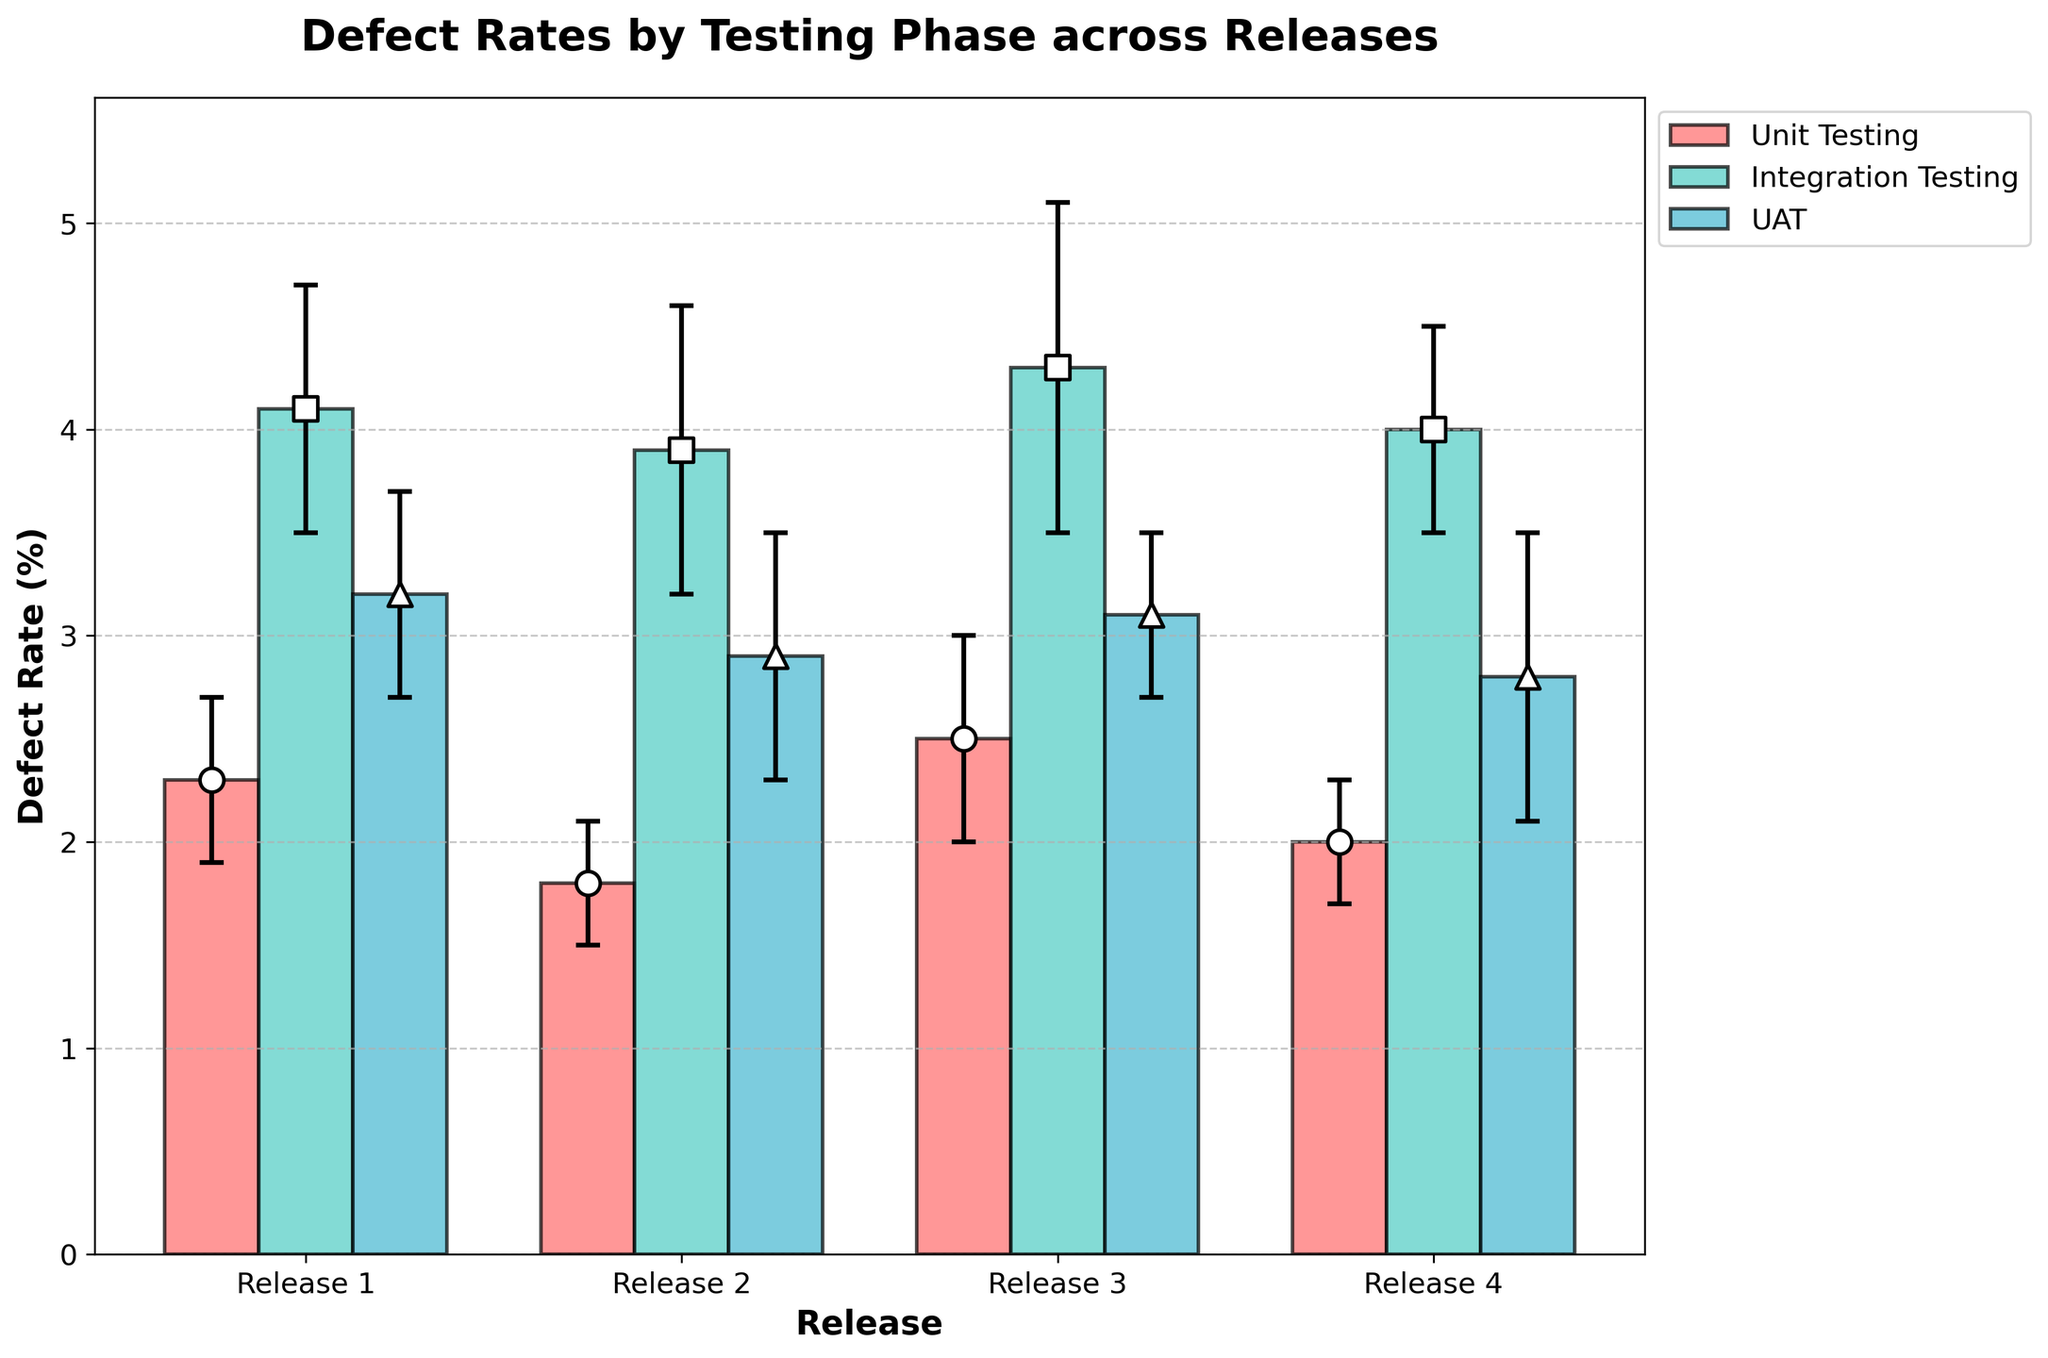What's the title of the figure? The title of the figure is usually prominently displayed at the top. In this figure, the title is "Defect Rates by Testing Phase across Releases".
Answer: Defect Rates by Testing Phase across Releases Which testing phase has the highest defect rate in Release 1? By looking at the defect rates in Release 1, Integration Testing has the highest defect rate, which is 4.1%.
Answer: Integration Testing What is the defect rate for UAT in Release 3? By locating Release 3 on the x-axis and then finding the UAT series, the defect rate is 3.1%.
Answer: 3.1% Which release has the highest defect rate in unit testing? By comparing the defect rates across all releases in the unit testing phase, Release 3 has the highest defect rate at 2.5%.
Answer: Release 3 How does the defect rate in integration testing for Release 2 compare to Release 3? For Release 2, the defect rate in integration testing is 3.9%, while for Release 3, it is 4.3%. Comparing these, Release 3 has a higher defect rate by 0.4%.
Answer: Release 3 is higher by 0.4% What is the average defect rate across all phases for Release 4? The defect rates for Release 4 are 2.0% (Unit Testing), 4.0% (Integration Testing), and 2.8% (UAT). Adding these and dividing by 3 gives (2.0 + 4.0 + 2.8)/3 = 2.93%.
Answer: 2.93% Which testing phase shows the smallest error margin in Release 2? By comparing the error margins for all testing phases in Release 2: 0.3% (Unit Testing), 0.7% (Integration Testing), and 0.6% (UAT), Unit Testing has the smallest error margin of 0.3%.
Answer: Unit Testing What is the range of defect rates in integration testing across all releases? The defect rates in integration testing across releases are: Release 1: 4.1%, Release 2: 3.9%, Release 3: 4.3%, Release 4: 4.0%. The range is the difference between the highest and lowest values, so 4.3% - 3.9% = 0.4%.
Answer: 0.4% During which phase and release is the defect rate closest to 3.0%? Comparing defect rates to 3.0% from all phases and releases, Release 4 UAT has a defect rate of 2.8%, which is closest to 3.0%.
Answer: Release 4 UAT 